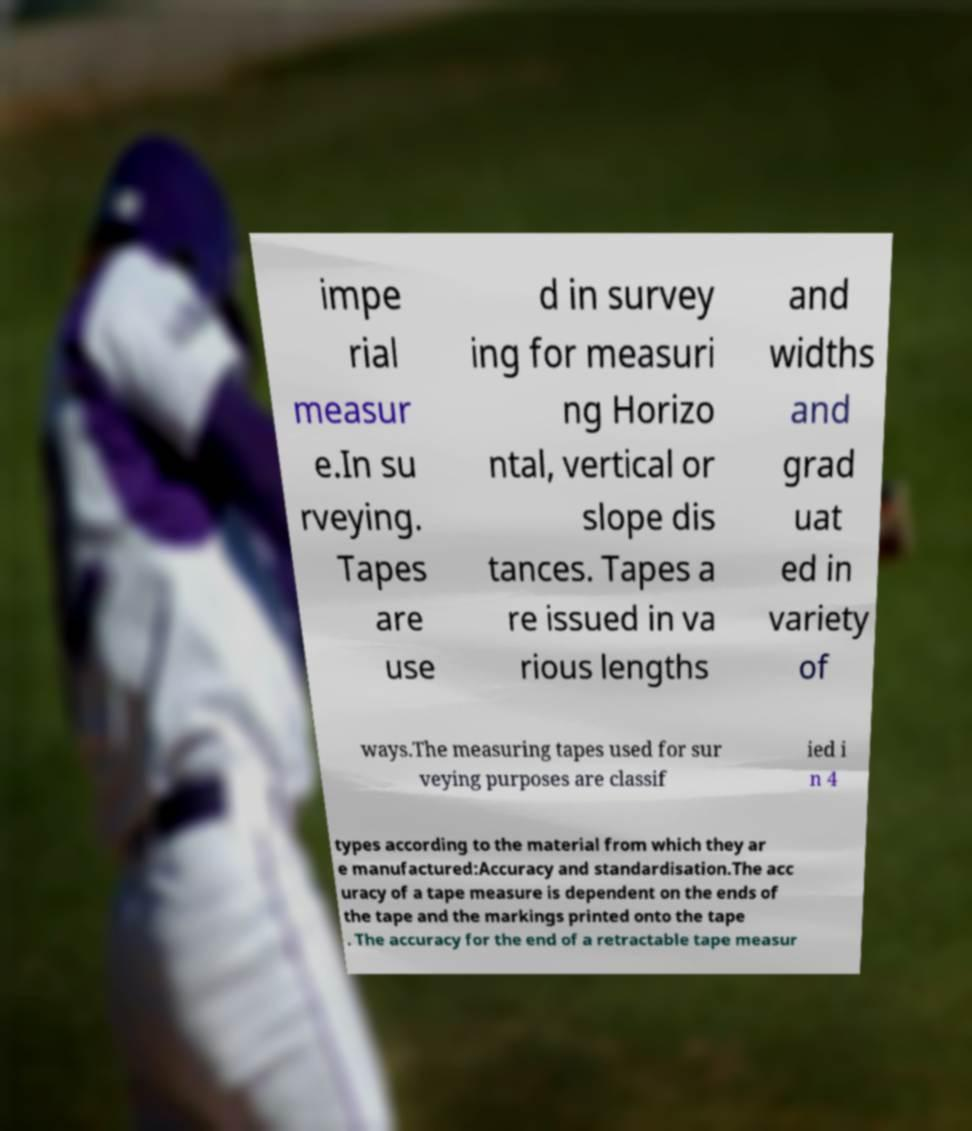Could you assist in decoding the text presented in this image and type it out clearly? impe rial measur e.In su rveying. Tapes are use d in survey ing for measuri ng Horizo ntal, vertical or slope dis tances. Tapes a re issued in va rious lengths and widths and grad uat ed in variety of ways.The measuring tapes used for sur veying purposes are classif ied i n 4 types according to the material from which they ar e manufactured:Accuracy and standardisation.The acc uracy of a tape measure is dependent on the ends of the tape and the markings printed onto the tape . The accuracy for the end of a retractable tape measur 